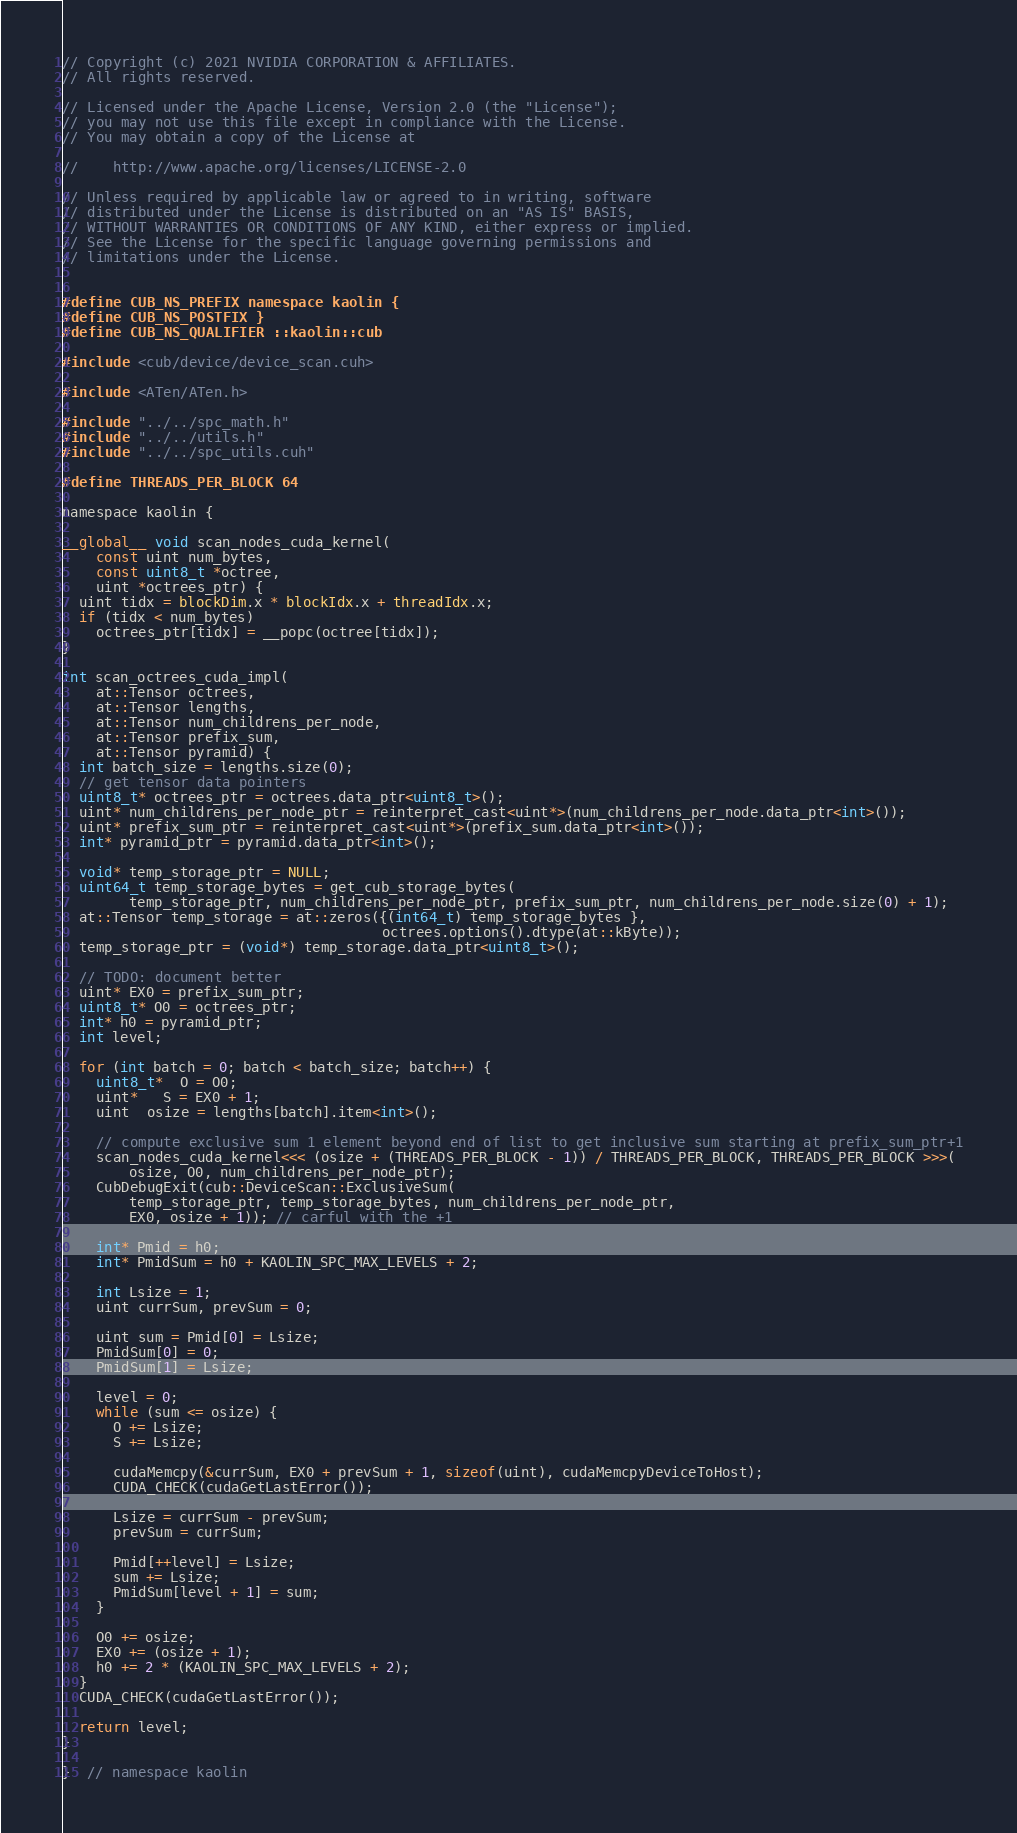Convert code to text. <code><loc_0><loc_0><loc_500><loc_500><_Cuda_>// Copyright (c) 2021 NVIDIA CORPORATION & AFFILIATES.
// All rights reserved.

// Licensed under the Apache License, Version 2.0 (the "License");
// you may not use this file except in compliance with the License.
// You may obtain a copy of the License at

//    http://www.apache.org/licenses/LICENSE-2.0

// Unless required by applicable law or agreed to in writing, software
// distributed under the License is distributed on an "AS IS" BASIS,
// WITHOUT WARRANTIES OR CONDITIONS OF ANY KIND, either express or implied.
// See the License for the specific language governing permissions and
// limitations under the License.


#define CUB_NS_PREFIX namespace kaolin {
#define CUB_NS_POSTFIX }
#define CUB_NS_QUALIFIER ::kaolin::cub

#include <cub/device/device_scan.cuh>

#include <ATen/ATen.h>

#include "../../spc_math.h"
#include "../../utils.h"
#include "../../spc_utils.cuh"

#define THREADS_PER_BLOCK 64

namespace kaolin {

__global__ void scan_nodes_cuda_kernel(
    const uint num_bytes,
    const uint8_t *octree,
    uint *octrees_ptr) {
  uint tidx = blockDim.x * blockIdx.x + threadIdx.x;
  if (tidx < num_bytes)
    octrees_ptr[tidx] = __popc(octree[tidx]);
}

int scan_octrees_cuda_impl(
    at::Tensor octrees,
    at::Tensor lengths,
    at::Tensor num_childrens_per_node,
    at::Tensor prefix_sum,
    at::Tensor pyramid) {
  int batch_size = lengths.size(0);
  // get tensor data pointers
  uint8_t* octrees_ptr = octrees.data_ptr<uint8_t>();
  uint* num_childrens_per_node_ptr = reinterpret_cast<uint*>(num_childrens_per_node.data_ptr<int>());
  uint* prefix_sum_ptr = reinterpret_cast<uint*>(prefix_sum.data_ptr<int>());
  int* pyramid_ptr = pyramid.data_ptr<int>();
  
  void* temp_storage_ptr = NULL;
  uint64_t temp_storage_bytes = get_cub_storage_bytes(
        temp_storage_ptr, num_childrens_per_node_ptr, prefix_sum_ptr, num_childrens_per_node.size(0) + 1);
  at::Tensor temp_storage = at::zeros({(int64_t) temp_storage_bytes },
                                      octrees.options().dtype(at::kByte));
  temp_storage_ptr = (void*) temp_storage.data_ptr<uint8_t>();

  // TODO: document better
  uint* EX0 = prefix_sum_ptr;
  uint8_t* O0 = octrees_ptr;
  int* h0 = pyramid_ptr;
  int level;

  for (int batch = 0; batch < batch_size; batch++) {
    uint8_t*  O = O0;
    uint*   S = EX0 + 1;
    uint  osize = lengths[batch].item<int>();

    // compute exclusive sum 1 element beyond end of list to get inclusive sum starting at prefix_sum_ptr+1
    scan_nodes_cuda_kernel<<< (osize + (THREADS_PER_BLOCK - 1)) / THREADS_PER_BLOCK, THREADS_PER_BLOCK >>>(
        osize, O0, num_childrens_per_node_ptr);
    CubDebugExit(cub::DeviceScan::ExclusiveSum(
        temp_storage_ptr, temp_storage_bytes, num_childrens_per_node_ptr,
        EX0, osize + 1)); // carful with the +1

    int* Pmid = h0;
    int* PmidSum = h0 + KAOLIN_SPC_MAX_LEVELS + 2;

    int Lsize = 1;
    uint currSum, prevSum = 0;

    uint sum = Pmid[0] = Lsize;
    PmidSum[0] = 0;
    PmidSum[1] = Lsize;

    level = 0;
    while (sum <= osize) {
      O += Lsize;
      S += Lsize;

      cudaMemcpy(&currSum, EX0 + prevSum + 1, sizeof(uint), cudaMemcpyDeviceToHost);
      CUDA_CHECK(cudaGetLastError());

      Lsize = currSum - prevSum;
      prevSum = currSum;

      Pmid[++level] = Lsize;
      sum += Lsize;
      PmidSum[level + 1] = sum;
    }

    O0 += osize;
    EX0 += (osize + 1);
    h0 += 2 * (KAOLIN_SPC_MAX_LEVELS + 2);
  }
  CUDA_CHECK(cudaGetLastError());

  return level;
}

}  // namespace kaolin
</code> 